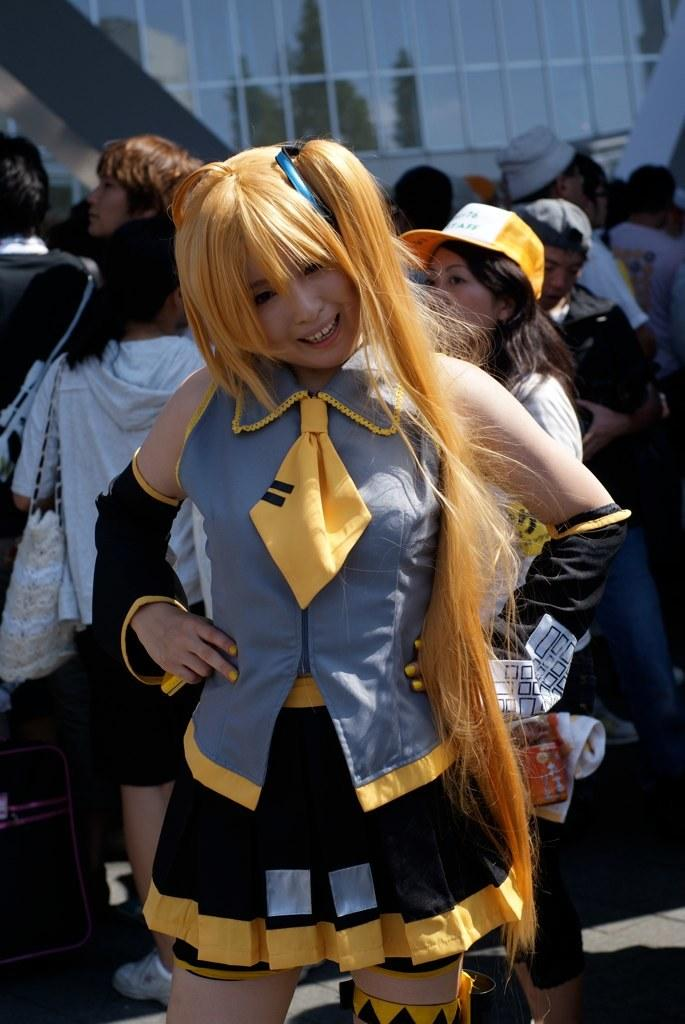Who is the main subject in the image? There is a woman standing in the center of the image. What is the woman doing in the image? The woman is smiling. What can be seen in the background of the image? There is a glass building and people standing in the background of the image. What type of loaf is the woman holding in the image? There is no loaf present in the image; the woman is not holding anything. Does the woman appear to have any regrets in the image? The image does not convey any emotions or thoughts of regret; the woman is simply smiling. 